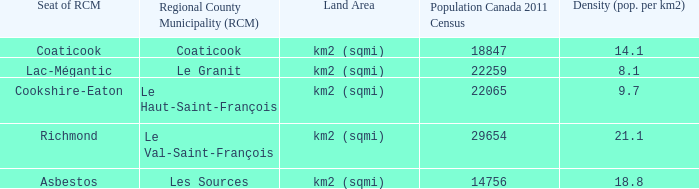What is the land area for the RCM that has a population of 18847? Km2 (sqmi). 